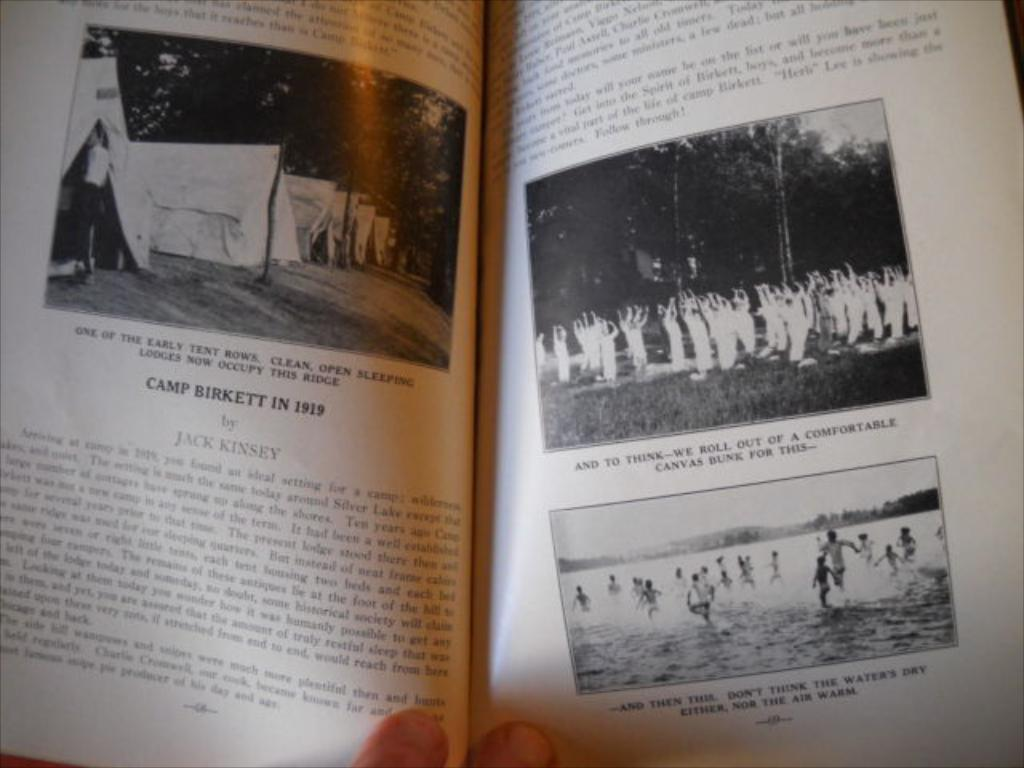<image>
Render a clear and concise summary of the photo. A book is open to a page about Camp Birkett in 1919. 